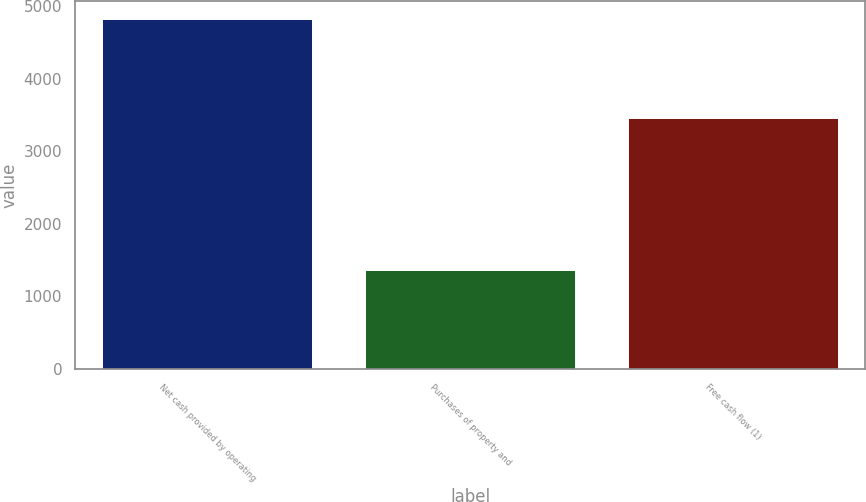Convert chart to OTSL. <chart><loc_0><loc_0><loc_500><loc_500><bar_chart><fcel>Net cash provided by operating<fcel>Purchases of property and<fcel>Free cash flow (1)<nl><fcel>4831<fcel>1362<fcel>3458<nl></chart> 